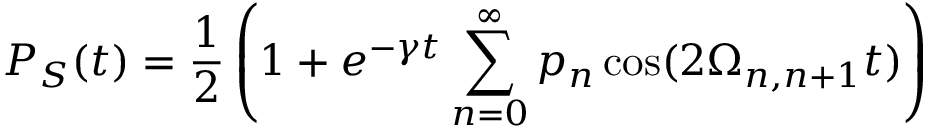Convert formula to latex. <formula><loc_0><loc_0><loc_500><loc_500>P _ { S } ( t ) = \frac { 1 } { 2 } \left ( 1 + e ^ { - \gamma t } \sum _ { n = 0 } ^ { \infty } p _ { n } \cos ( 2 \Omega _ { n , n + 1 } t ) \right )</formula> 